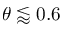Convert formula to latex. <formula><loc_0><loc_0><loc_500><loc_500>\theta \lessapprox 0 . 6</formula> 